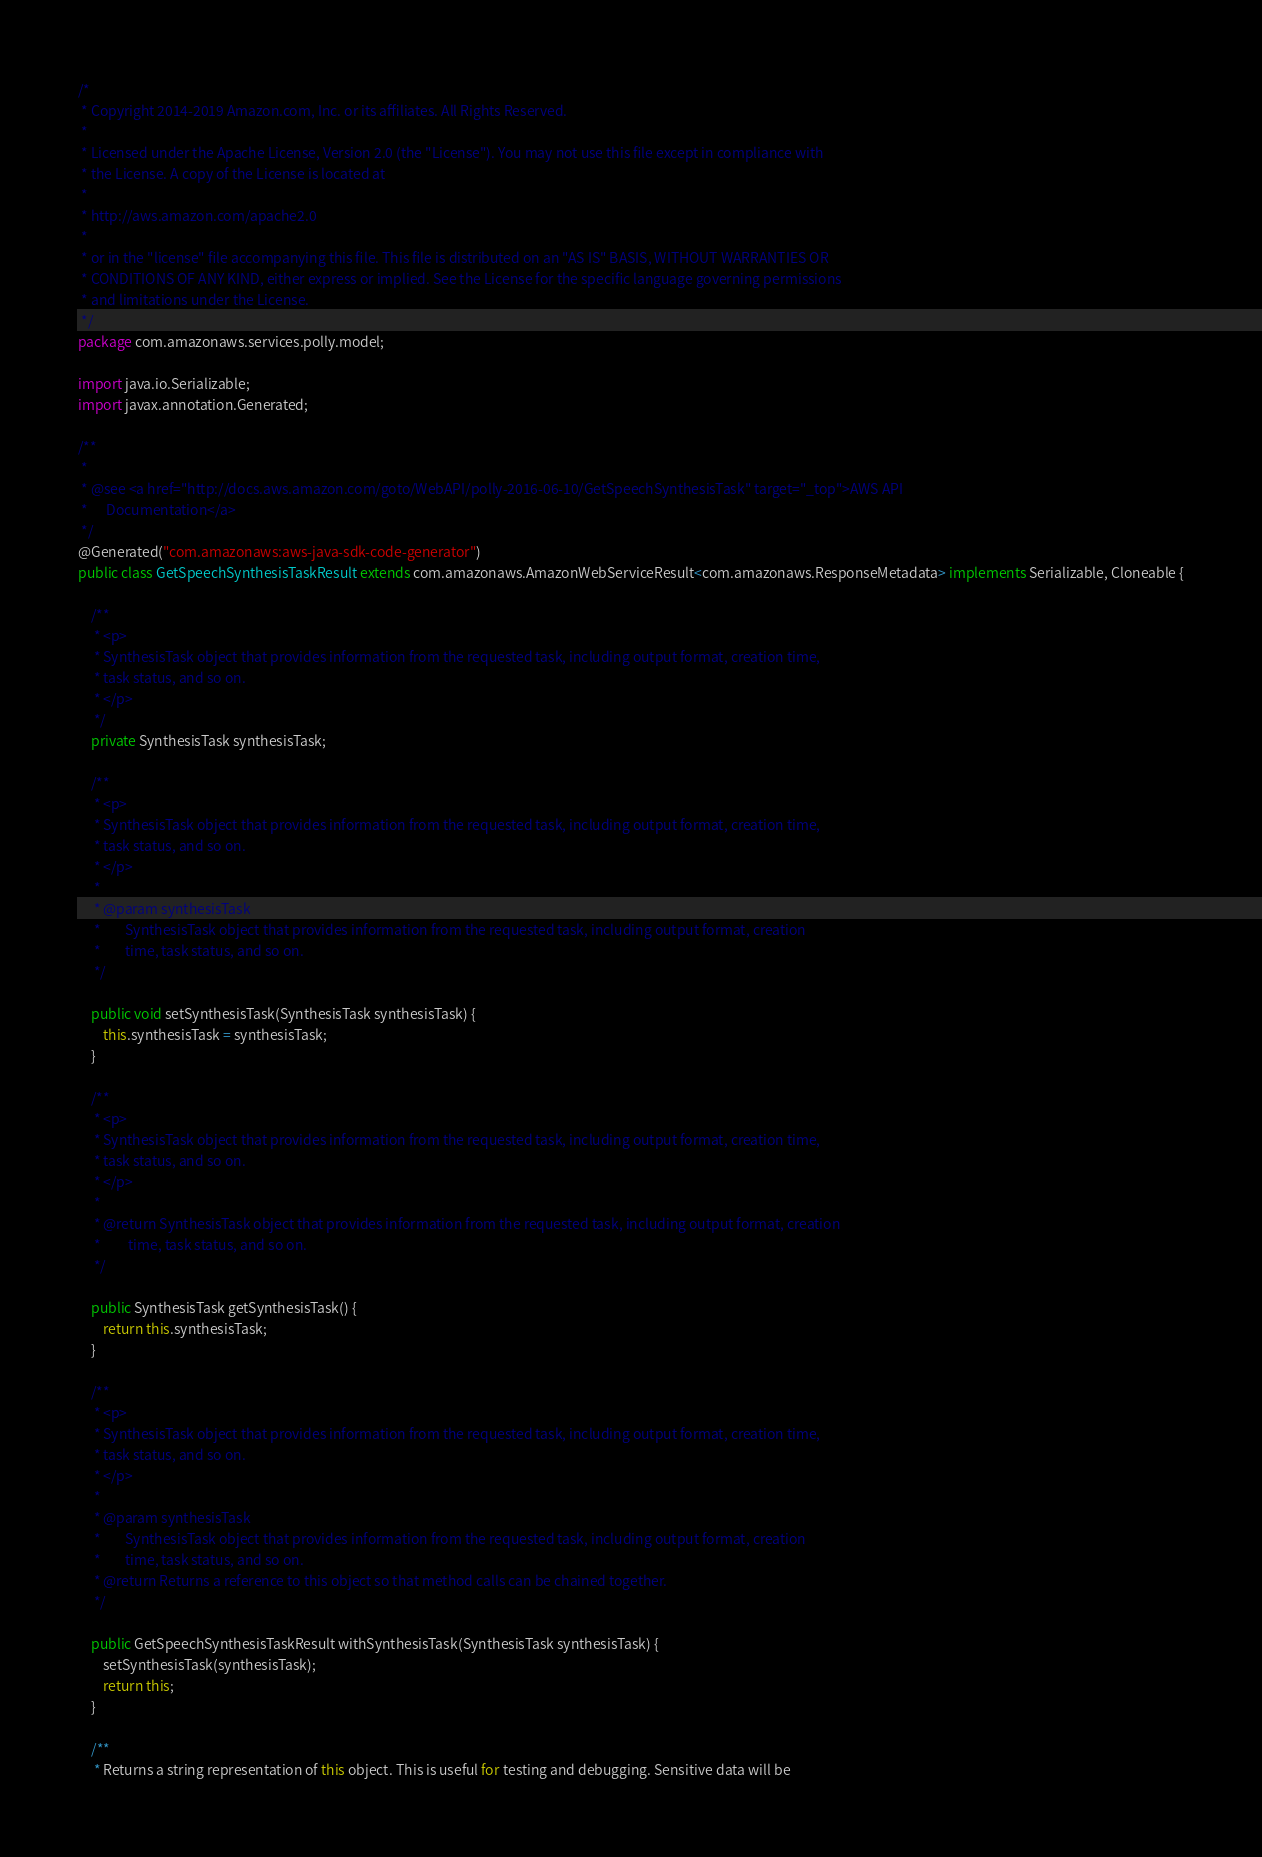Convert code to text. <code><loc_0><loc_0><loc_500><loc_500><_Java_>/*
 * Copyright 2014-2019 Amazon.com, Inc. or its affiliates. All Rights Reserved.
 * 
 * Licensed under the Apache License, Version 2.0 (the "License"). You may not use this file except in compliance with
 * the License. A copy of the License is located at
 * 
 * http://aws.amazon.com/apache2.0
 * 
 * or in the "license" file accompanying this file. This file is distributed on an "AS IS" BASIS, WITHOUT WARRANTIES OR
 * CONDITIONS OF ANY KIND, either express or implied. See the License for the specific language governing permissions
 * and limitations under the License.
 */
package com.amazonaws.services.polly.model;

import java.io.Serializable;
import javax.annotation.Generated;

/**
 * 
 * @see <a href="http://docs.aws.amazon.com/goto/WebAPI/polly-2016-06-10/GetSpeechSynthesisTask" target="_top">AWS API
 *      Documentation</a>
 */
@Generated("com.amazonaws:aws-java-sdk-code-generator")
public class GetSpeechSynthesisTaskResult extends com.amazonaws.AmazonWebServiceResult<com.amazonaws.ResponseMetadata> implements Serializable, Cloneable {

    /**
     * <p>
     * SynthesisTask object that provides information from the requested task, including output format, creation time,
     * task status, and so on.
     * </p>
     */
    private SynthesisTask synthesisTask;

    /**
     * <p>
     * SynthesisTask object that provides information from the requested task, including output format, creation time,
     * task status, and so on.
     * </p>
     * 
     * @param synthesisTask
     *        SynthesisTask object that provides information from the requested task, including output format, creation
     *        time, task status, and so on.
     */

    public void setSynthesisTask(SynthesisTask synthesisTask) {
        this.synthesisTask = synthesisTask;
    }

    /**
     * <p>
     * SynthesisTask object that provides information from the requested task, including output format, creation time,
     * task status, and so on.
     * </p>
     * 
     * @return SynthesisTask object that provides information from the requested task, including output format, creation
     *         time, task status, and so on.
     */

    public SynthesisTask getSynthesisTask() {
        return this.synthesisTask;
    }

    /**
     * <p>
     * SynthesisTask object that provides information from the requested task, including output format, creation time,
     * task status, and so on.
     * </p>
     * 
     * @param synthesisTask
     *        SynthesisTask object that provides information from the requested task, including output format, creation
     *        time, task status, and so on.
     * @return Returns a reference to this object so that method calls can be chained together.
     */

    public GetSpeechSynthesisTaskResult withSynthesisTask(SynthesisTask synthesisTask) {
        setSynthesisTask(synthesisTask);
        return this;
    }

    /**
     * Returns a string representation of this object. This is useful for testing and debugging. Sensitive data will be</code> 